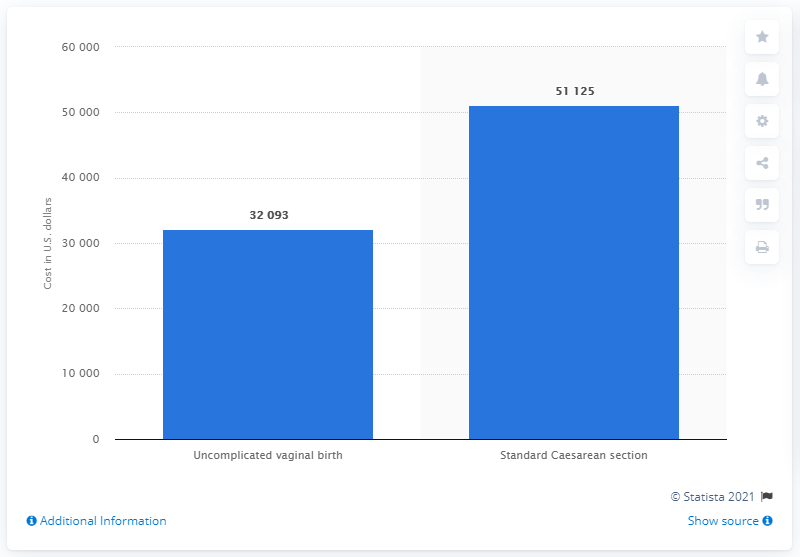Outline some significant characteristics in this image. According to data from 2013, the average cost of an uncomplicated vaginal birth was approximately 32,093 U.S. dollars. The average cost of a standard Cesarean section birth in 2013 was approximately $51,125. 